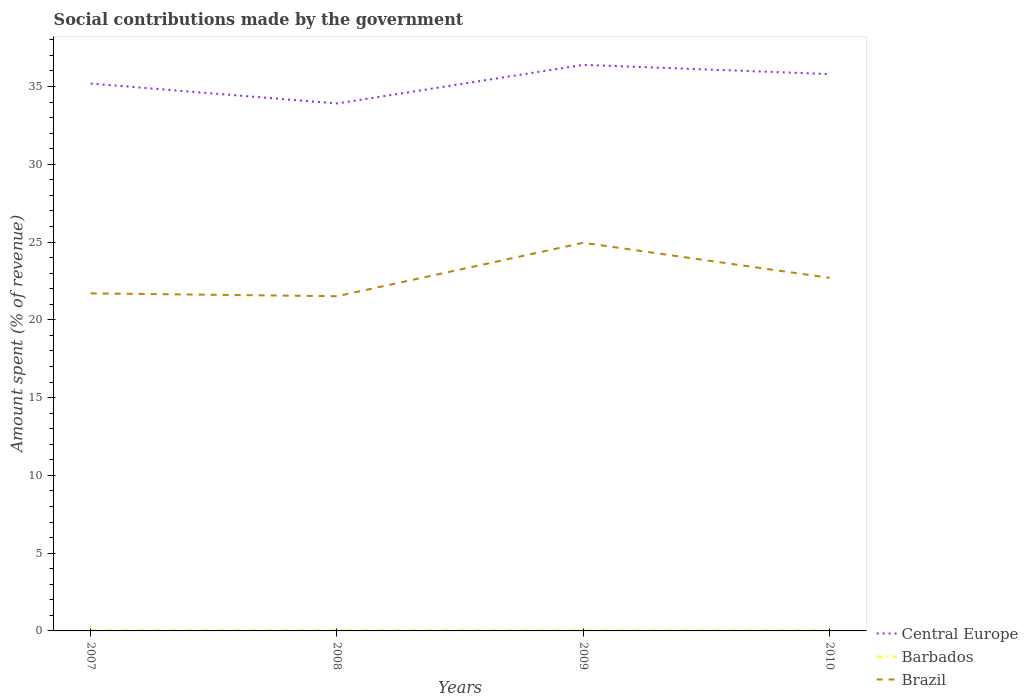How many different coloured lines are there?
Your answer should be very brief. 3. Does the line corresponding to Barbados intersect with the line corresponding to Brazil?
Keep it short and to the point. No. Is the number of lines equal to the number of legend labels?
Give a very brief answer. Yes. Across all years, what is the maximum amount spent (in %) on social contributions in Barbados?
Ensure brevity in your answer.  0.03. What is the total amount spent (in %) on social contributions in Brazil in the graph?
Ensure brevity in your answer.  0.18. What is the difference between the highest and the second highest amount spent (in %) on social contributions in Central Europe?
Make the answer very short. 2.48. Is the amount spent (in %) on social contributions in Brazil strictly greater than the amount spent (in %) on social contributions in Barbados over the years?
Your response must be concise. No. How many lines are there?
Offer a very short reply. 3. Are the values on the major ticks of Y-axis written in scientific E-notation?
Your answer should be compact. No. Does the graph contain any zero values?
Ensure brevity in your answer.  No. Where does the legend appear in the graph?
Keep it short and to the point. Bottom right. How many legend labels are there?
Make the answer very short. 3. What is the title of the graph?
Give a very brief answer. Social contributions made by the government. Does "Nicaragua" appear as one of the legend labels in the graph?
Ensure brevity in your answer.  No. What is the label or title of the Y-axis?
Your answer should be compact. Amount spent (% of revenue). What is the Amount spent (% of revenue) in Central Europe in 2007?
Your answer should be compact. 35.19. What is the Amount spent (% of revenue) in Barbados in 2007?
Your answer should be compact. 0.04. What is the Amount spent (% of revenue) in Brazil in 2007?
Offer a very short reply. 21.7. What is the Amount spent (% of revenue) in Central Europe in 2008?
Give a very brief answer. 33.91. What is the Amount spent (% of revenue) of Barbados in 2008?
Your answer should be compact. 0.04. What is the Amount spent (% of revenue) of Brazil in 2008?
Give a very brief answer. 21.52. What is the Amount spent (% of revenue) of Central Europe in 2009?
Offer a very short reply. 36.39. What is the Amount spent (% of revenue) in Barbados in 2009?
Ensure brevity in your answer.  0.03. What is the Amount spent (% of revenue) of Brazil in 2009?
Keep it short and to the point. 24.95. What is the Amount spent (% of revenue) in Central Europe in 2010?
Your answer should be compact. 35.8. What is the Amount spent (% of revenue) of Barbados in 2010?
Your response must be concise. 0.03. What is the Amount spent (% of revenue) in Brazil in 2010?
Your answer should be very brief. 22.7. Across all years, what is the maximum Amount spent (% of revenue) of Central Europe?
Make the answer very short. 36.39. Across all years, what is the maximum Amount spent (% of revenue) in Barbados?
Provide a short and direct response. 0.04. Across all years, what is the maximum Amount spent (% of revenue) of Brazil?
Your answer should be compact. 24.95. Across all years, what is the minimum Amount spent (% of revenue) in Central Europe?
Your response must be concise. 33.91. Across all years, what is the minimum Amount spent (% of revenue) in Barbados?
Provide a succinct answer. 0.03. Across all years, what is the minimum Amount spent (% of revenue) of Brazil?
Offer a terse response. 21.52. What is the total Amount spent (% of revenue) in Central Europe in the graph?
Your response must be concise. 141.29. What is the total Amount spent (% of revenue) of Barbados in the graph?
Provide a short and direct response. 0.14. What is the total Amount spent (% of revenue) in Brazil in the graph?
Offer a terse response. 90.87. What is the difference between the Amount spent (% of revenue) in Central Europe in 2007 and that in 2008?
Offer a terse response. 1.28. What is the difference between the Amount spent (% of revenue) of Barbados in 2007 and that in 2008?
Offer a very short reply. 0. What is the difference between the Amount spent (% of revenue) in Brazil in 2007 and that in 2008?
Your response must be concise. 0.18. What is the difference between the Amount spent (% of revenue) of Central Europe in 2007 and that in 2009?
Offer a terse response. -1.2. What is the difference between the Amount spent (% of revenue) in Barbados in 2007 and that in 2009?
Your answer should be very brief. 0.01. What is the difference between the Amount spent (% of revenue) of Brazil in 2007 and that in 2009?
Keep it short and to the point. -3.25. What is the difference between the Amount spent (% of revenue) of Central Europe in 2007 and that in 2010?
Provide a short and direct response. -0.61. What is the difference between the Amount spent (% of revenue) in Barbados in 2007 and that in 2010?
Keep it short and to the point. 0.01. What is the difference between the Amount spent (% of revenue) in Brazil in 2007 and that in 2010?
Provide a short and direct response. -1. What is the difference between the Amount spent (% of revenue) of Central Europe in 2008 and that in 2009?
Keep it short and to the point. -2.48. What is the difference between the Amount spent (% of revenue) of Barbados in 2008 and that in 2009?
Offer a terse response. 0.01. What is the difference between the Amount spent (% of revenue) of Brazil in 2008 and that in 2009?
Give a very brief answer. -3.44. What is the difference between the Amount spent (% of revenue) in Central Europe in 2008 and that in 2010?
Ensure brevity in your answer.  -1.89. What is the difference between the Amount spent (% of revenue) of Barbados in 2008 and that in 2010?
Offer a very short reply. 0. What is the difference between the Amount spent (% of revenue) of Brazil in 2008 and that in 2010?
Ensure brevity in your answer.  -1.18. What is the difference between the Amount spent (% of revenue) of Central Europe in 2009 and that in 2010?
Make the answer very short. 0.59. What is the difference between the Amount spent (% of revenue) of Barbados in 2009 and that in 2010?
Provide a succinct answer. -0. What is the difference between the Amount spent (% of revenue) of Brazil in 2009 and that in 2010?
Give a very brief answer. 2.26. What is the difference between the Amount spent (% of revenue) of Central Europe in 2007 and the Amount spent (% of revenue) of Barbados in 2008?
Offer a terse response. 35.15. What is the difference between the Amount spent (% of revenue) of Central Europe in 2007 and the Amount spent (% of revenue) of Brazil in 2008?
Provide a short and direct response. 13.67. What is the difference between the Amount spent (% of revenue) in Barbados in 2007 and the Amount spent (% of revenue) in Brazil in 2008?
Keep it short and to the point. -21.48. What is the difference between the Amount spent (% of revenue) of Central Europe in 2007 and the Amount spent (% of revenue) of Barbados in 2009?
Give a very brief answer. 35.16. What is the difference between the Amount spent (% of revenue) in Central Europe in 2007 and the Amount spent (% of revenue) in Brazil in 2009?
Give a very brief answer. 10.24. What is the difference between the Amount spent (% of revenue) in Barbados in 2007 and the Amount spent (% of revenue) in Brazil in 2009?
Your response must be concise. -24.91. What is the difference between the Amount spent (% of revenue) in Central Europe in 2007 and the Amount spent (% of revenue) in Barbados in 2010?
Provide a succinct answer. 35.16. What is the difference between the Amount spent (% of revenue) of Central Europe in 2007 and the Amount spent (% of revenue) of Brazil in 2010?
Your answer should be compact. 12.49. What is the difference between the Amount spent (% of revenue) in Barbados in 2007 and the Amount spent (% of revenue) in Brazil in 2010?
Offer a very short reply. -22.66. What is the difference between the Amount spent (% of revenue) of Central Europe in 2008 and the Amount spent (% of revenue) of Barbados in 2009?
Keep it short and to the point. 33.88. What is the difference between the Amount spent (% of revenue) in Central Europe in 2008 and the Amount spent (% of revenue) in Brazil in 2009?
Offer a very short reply. 8.96. What is the difference between the Amount spent (% of revenue) in Barbados in 2008 and the Amount spent (% of revenue) in Brazil in 2009?
Your answer should be compact. -24.92. What is the difference between the Amount spent (% of revenue) in Central Europe in 2008 and the Amount spent (% of revenue) in Barbados in 2010?
Your response must be concise. 33.88. What is the difference between the Amount spent (% of revenue) in Central Europe in 2008 and the Amount spent (% of revenue) in Brazil in 2010?
Make the answer very short. 11.21. What is the difference between the Amount spent (% of revenue) in Barbados in 2008 and the Amount spent (% of revenue) in Brazil in 2010?
Offer a terse response. -22.66. What is the difference between the Amount spent (% of revenue) in Central Europe in 2009 and the Amount spent (% of revenue) in Barbados in 2010?
Ensure brevity in your answer.  36.36. What is the difference between the Amount spent (% of revenue) of Central Europe in 2009 and the Amount spent (% of revenue) of Brazil in 2010?
Your response must be concise. 13.7. What is the difference between the Amount spent (% of revenue) in Barbados in 2009 and the Amount spent (% of revenue) in Brazil in 2010?
Your response must be concise. -22.67. What is the average Amount spent (% of revenue) in Central Europe per year?
Your answer should be compact. 35.32. What is the average Amount spent (% of revenue) in Barbados per year?
Your answer should be compact. 0.03. What is the average Amount spent (% of revenue) of Brazil per year?
Provide a short and direct response. 22.72. In the year 2007, what is the difference between the Amount spent (% of revenue) in Central Europe and Amount spent (% of revenue) in Barbados?
Offer a very short reply. 35.15. In the year 2007, what is the difference between the Amount spent (% of revenue) in Central Europe and Amount spent (% of revenue) in Brazil?
Give a very brief answer. 13.49. In the year 2007, what is the difference between the Amount spent (% of revenue) of Barbados and Amount spent (% of revenue) of Brazil?
Keep it short and to the point. -21.66. In the year 2008, what is the difference between the Amount spent (% of revenue) of Central Europe and Amount spent (% of revenue) of Barbados?
Make the answer very short. 33.87. In the year 2008, what is the difference between the Amount spent (% of revenue) in Central Europe and Amount spent (% of revenue) in Brazil?
Make the answer very short. 12.39. In the year 2008, what is the difference between the Amount spent (% of revenue) of Barbados and Amount spent (% of revenue) of Brazil?
Provide a short and direct response. -21.48. In the year 2009, what is the difference between the Amount spent (% of revenue) in Central Europe and Amount spent (% of revenue) in Barbados?
Give a very brief answer. 36.36. In the year 2009, what is the difference between the Amount spent (% of revenue) of Central Europe and Amount spent (% of revenue) of Brazil?
Keep it short and to the point. 11.44. In the year 2009, what is the difference between the Amount spent (% of revenue) in Barbados and Amount spent (% of revenue) in Brazil?
Your answer should be compact. -24.92. In the year 2010, what is the difference between the Amount spent (% of revenue) in Central Europe and Amount spent (% of revenue) in Barbados?
Your answer should be compact. 35.77. In the year 2010, what is the difference between the Amount spent (% of revenue) in Central Europe and Amount spent (% of revenue) in Brazil?
Keep it short and to the point. 13.1. In the year 2010, what is the difference between the Amount spent (% of revenue) in Barbados and Amount spent (% of revenue) in Brazil?
Ensure brevity in your answer.  -22.66. What is the ratio of the Amount spent (% of revenue) of Central Europe in 2007 to that in 2008?
Your answer should be very brief. 1.04. What is the ratio of the Amount spent (% of revenue) in Barbados in 2007 to that in 2008?
Your answer should be very brief. 1.12. What is the ratio of the Amount spent (% of revenue) of Brazil in 2007 to that in 2008?
Your response must be concise. 1.01. What is the ratio of the Amount spent (% of revenue) of Central Europe in 2007 to that in 2009?
Provide a succinct answer. 0.97. What is the ratio of the Amount spent (% of revenue) in Barbados in 2007 to that in 2009?
Offer a very short reply. 1.35. What is the ratio of the Amount spent (% of revenue) in Brazil in 2007 to that in 2009?
Ensure brevity in your answer.  0.87. What is the ratio of the Amount spent (% of revenue) in Central Europe in 2007 to that in 2010?
Your response must be concise. 0.98. What is the ratio of the Amount spent (% of revenue) in Barbados in 2007 to that in 2010?
Your response must be concise. 1.25. What is the ratio of the Amount spent (% of revenue) of Brazil in 2007 to that in 2010?
Offer a terse response. 0.96. What is the ratio of the Amount spent (% of revenue) of Central Europe in 2008 to that in 2009?
Your answer should be compact. 0.93. What is the ratio of the Amount spent (% of revenue) in Barbados in 2008 to that in 2009?
Keep it short and to the point. 1.21. What is the ratio of the Amount spent (% of revenue) in Brazil in 2008 to that in 2009?
Provide a short and direct response. 0.86. What is the ratio of the Amount spent (% of revenue) in Central Europe in 2008 to that in 2010?
Offer a very short reply. 0.95. What is the ratio of the Amount spent (% of revenue) in Barbados in 2008 to that in 2010?
Make the answer very short. 1.12. What is the ratio of the Amount spent (% of revenue) of Brazil in 2008 to that in 2010?
Ensure brevity in your answer.  0.95. What is the ratio of the Amount spent (% of revenue) in Central Europe in 2009 to that in 2010?
Give a very brief answer. 1.02. What is the ratio of the Amount spent (% of revenue) in Barbados in 2009 to that in 2010?
Ensure brevity in your answer.  0.92. What is the ratio of the Amount spent (% of revenue) of Brazil in 2009 to that in 2010?
Your answer should be very brief. 1.1. What is the difference between the highest and the second highest Amount spent (% of revenue) of Central Europe?
Provide a short and direct response. 0.59. What is the difference between the highest and the second highest Amount spent (% of revenue) of Barbados?
Make the answer very short. 0. What is the difference between the highest and the second highest Amount spent (% of revenue) of Brazil?
Offer a terse response. 2.26. What is the difference between the highest and the lowest Amount spent (% of revenue) in Central Europe?
Give a very brief answer. 2.48. What is the difference between the highest and the lowest Amount spent (% of revenue) in Barbados?
Provide a succinct answer. 0.01. What is the difference between the highest and the lowest Amount spent (% of revenue) of Brazil?
Your answer should be very brief. 3.44. 